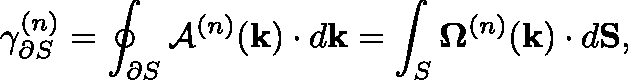<formula> <loc_0><loc_0><loc_500><loc_500>\gamma _ { \partial S } ^ { ( n ) } = \oint _ { \partial S } \mathcal { A } ^ { ( n ) } ( k ) \cdot d k = \int _ { S } { \Omega ^ { ( n ) } } ( k ) \cdot d S ,</formula> 